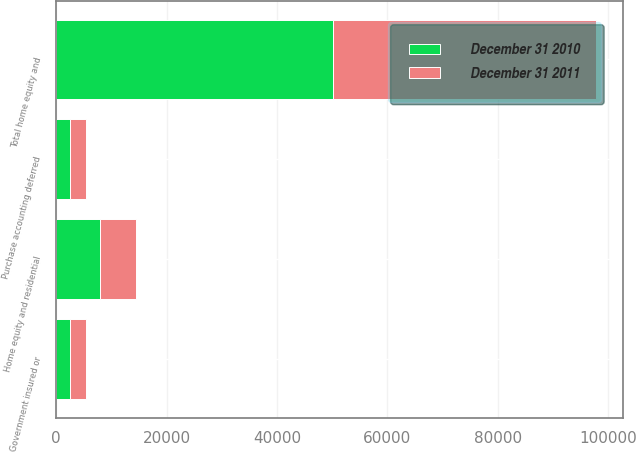<chart> <loc_0><loc_0><loc_500><loc_500><stacked_bar_chart><ecel><fcel>Home equity and residential<fcel>Government insured or<fcel>Purchase accounting deferred<fcel>Total home equity and<nl><fcel>December 31 2011<fcel>6533<fcel>2884<fcel>2873<fcel>47558<nl><fcel>December 31 2010<fcel>7924<fcel>2488<fcel>2485<fcel>50225<nl></chart> 